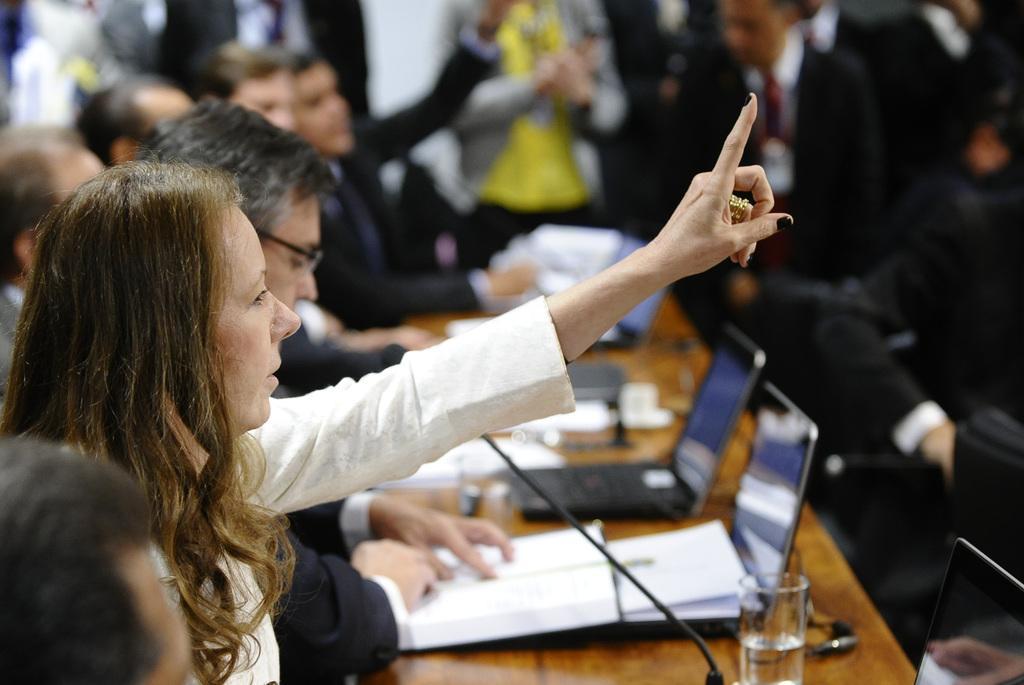Can you describe this image briefly? In this image there are group of persons sitting. In the center there is a table, on the table there are laptops, paper, there is a mic, there are glasses, cups and in the background there are persons standing. 